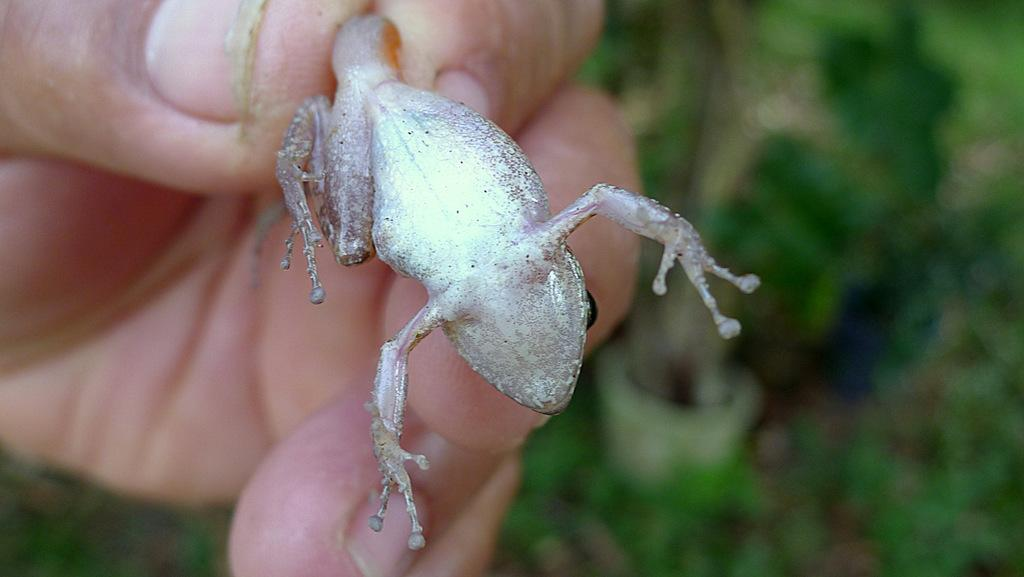What is being held in the image? A human hand is holding a frog in the image. Can you describe the frog's appearance? The frog is silver in color. What type of tray is being used to hold the frog in the image? There is no tray present in the image; the frog is being held by a human hand. What type of slip is the frog wearing in the image? The frog is not wearing any clothing or accessories in the image. 